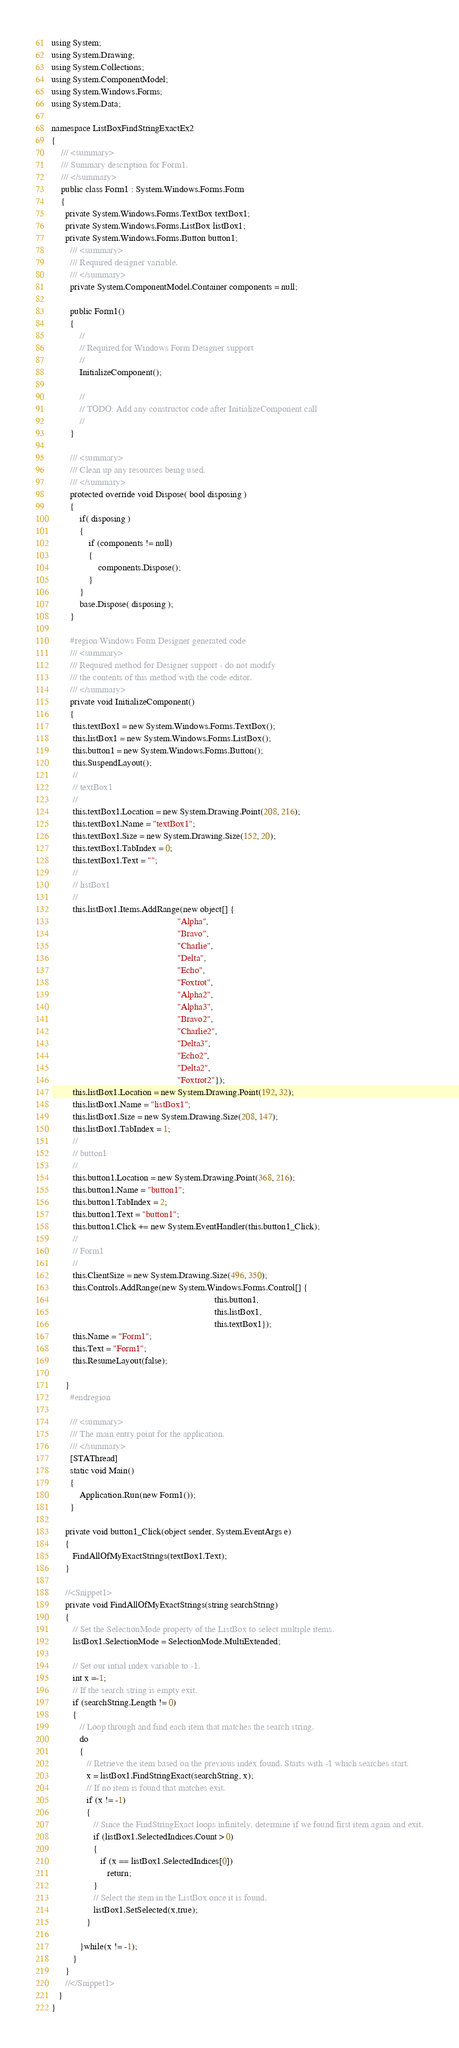<code> <loc_0><loc_0><loc_500><loc_500><_C#_>using System;
using System.Drawing;
using System.Collections;
using System.ComponentModel;
using System.Windows.Forms;
using System.Data;

namespace ListBoxFindStringExactEx2
{
	/// <summary>
	/// Summary description for Form1.
	/// </summary>
	public class Form1 : System.Windows.Forms.Form
	{
      private System.Windows.Forms.TextBox textBox1;
      private System.Windows.Forms.ListBox listBox1;
      private System.Windows.Forms.Button button1;
		/// <summary>
		/// Required designer variable.
		/// </summary>
		private System.ComponentModel.Container components = null;

		public Form1()
		{
			//
			// Required for Windows Form Designer support
			//
			InitializeComponent();

			//
			// TODO: Add any constructor code after InitializeComponent call
			//
		}

		/// <summary>
		/// Clean up any resources being used.
		/// </summary>
		protected override void Dispose( bool disposing )
		{
			if( disposing )
			{
				if (components != null) 
				{
					components.Dispose();
				}
			}
			base.Dispose( disposing );
		}

		#region Windows Form Designer generated code
		/// <summary>
		/// Required method for Designer support - do not modify
		/// the contents of this method with the code editor.
		/// </summary>
		private void InitializeComponent()
		{
         this.textBox1 = new System.Windows.Forms.TextBox();
         this.listBox1 = new System.Windows.Forms.ListBox();
         this.button1 = new System.Windows.Forms.Button();
         this.SuspendLayout();
         // 
         // textBox1
         // 
         this.textBox1.Location = new System.Drawing.Point(208, 216);
         this.textBox1.Name = "textBox1";
         this.textBox1.Size = new System.Drawing.Size(152, 20);
         this.textBox1.TabIndex = 0;
         this.textBox1.Text = "";
         // 
         // listBox1
         // 
         this.listBox1.Items.AddRange(new object[] {
                                                      "Alpha",
                                                      "Bravo",
                                                      "Charlie",
                                                      "Delta",
                                                      "Echo",
                                                      "Foxtrot",
                                                      "Alpha2",
                                                      "Alpha3",
                                                      "Bravo2",
                                                      "Charlie2",
                                                      "Delta3",
                                                      "Echo2",
                                                      "Delta2",
                                                      "Foxtrot2"});
         this.listBox1.Location = new System.Drawing.Point(192, 32);
         this.listBox1.Name = "listBox1";
         this.listBox1.Size = new System.Drawing.Size(208, 147);
         this.listBox1.TabIndex = 1;
         // 
         // button1
         // 
         this.button1.Location = new System.Drawing.Point(368, 216);
         this.button1.Name = "button1";
         this.button1.TabIndex = 2;
         this.button1.Text = "button1";
         this.button1.Click += new System.EventHandler(this.button1_Click);
         // 
         // Form1
         // 
         this.ClientSize = new System.Drawing.Size(496, 350);
         this.Controls.AddRange(new System.Windows.Forms.Control[] {
                                                                      this.button1,
                                                                      this.listBox1,
                                                                      this.textBox1});
         this.Name = "Form1";
         this.Text = "Form1";
         this.ResumeLayout(false);

      }
		#endregion

		/// <summary>
		/// The main entry point for the application.
		/// </summary>
		[STAThread]
		static void Main() 
		{
			Application.Run(new Form1());
		}

      private void button1_Click(object sender, System.EventArgs e)
      {
         FindAllOfMyExactStrings(textBox1.Text);
      }

      //<Snippet1>
      private void FindAllOfMyExactStrings(string searchString)
      {
         // Set the SelectionMode property of the ListBox to select multiple items.
         listBox1.SelectionMode = SelectionMode.MultiExtended;
         
         // Set our intial index variable to -1.
         int x =-1;
         // If the search string is empty exit.
         if (searchString.Length != 0)
         {
            // Loop through and find each item that matches the search string.
            do
            {
               // Retrieve the item based on the previous index found. Starts with -1 which searches start.
               x = listBox1.FindStringExact(searchString, x);
               // If no item is found that matches exit.
               if (x != -1)
               {
                  // Since the FindStringExact loops infinitely, determine if we found first item again and exit.
                  if (listBox1.SelectedIndices.Count > 0)
                  {
                     if (x == listBox1.SelectedIndices[0])
                        return;
                  }
                  // Select the item in the ListBox once it is found.
                  listBox1.SetSelected(x,true);
               }
   
            }while(x != -1);
         }
      }
      //</Snippet1>
   }
}

</code> 